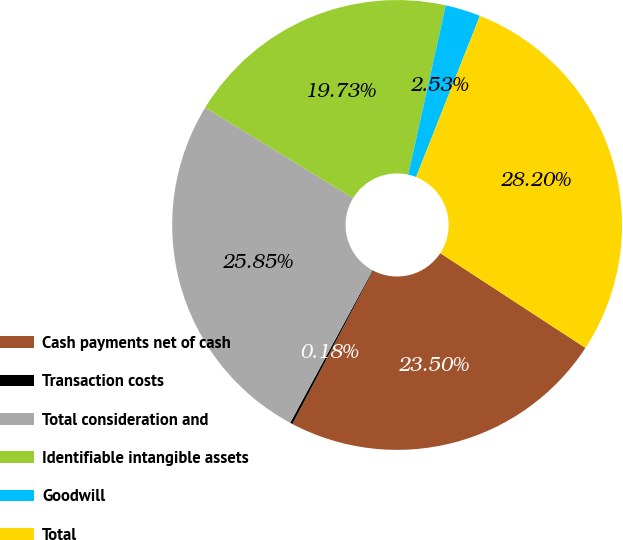Convert chart. <chart><loc_0><loc_0><loc_500><loc_500><pie_chart><fcel>Cash payments net of cash<fcel>Transaction costs<fcel>Total consideration and<fcel>Identifiable intangible assets<fcel>Goodwill<fcel>Total<nl><fcel>23.5%<fcel>0.18%<fcel>25.85%<fcel>19.73%<fcel>2.53%<fcel>28.2%<nl></chart> 